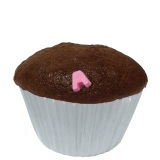Imagine this cupcake being transformed into a different dessert. What could it become? Imagine this cupcake being magically transformed into an elegant chocolate fondue fountain! The entire cupcake expands and grows, with streams of rich melted chocolate flowing gracefully down its sides. Around the base, it sprouts assorted fruits, marshmallows, and cookies ready for dipping. It would be an enchanting centerpiece for any dessert table!  What kind of event or scenario would perfectly feature this cupcake? This cupcake would be perfect for a kid's birthday party! The whimsical pink decoration on top would fit right in with a playful and colorful theme. It could also be a great addition to a casual get-together with friends or a cozy afternoon tea party. The charm and simplicity of a classic chocolate cupcake make it versatile for many joyous occasions. 